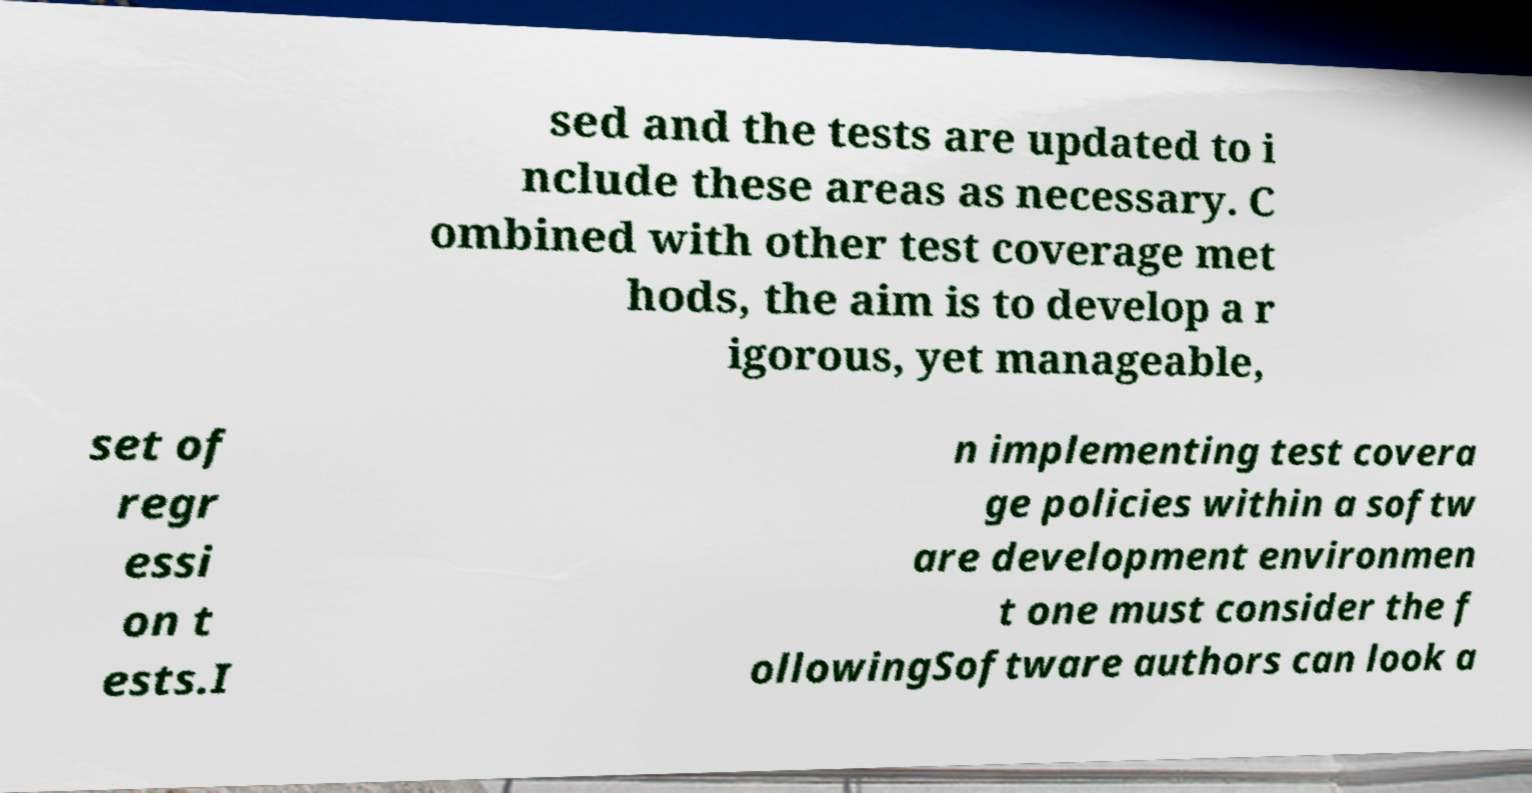Could you extract and type out the text from this image? sed and the tests are updated to i nclude these areas as necessary. C ombined with other test coverage met hods, the aim is to develop a r igorous, yet manageable, set of regr essi on t ests.I n implementing test covera ge policies within a softw are development environmen t one must consider the f ollowingSoftware authors can look a 